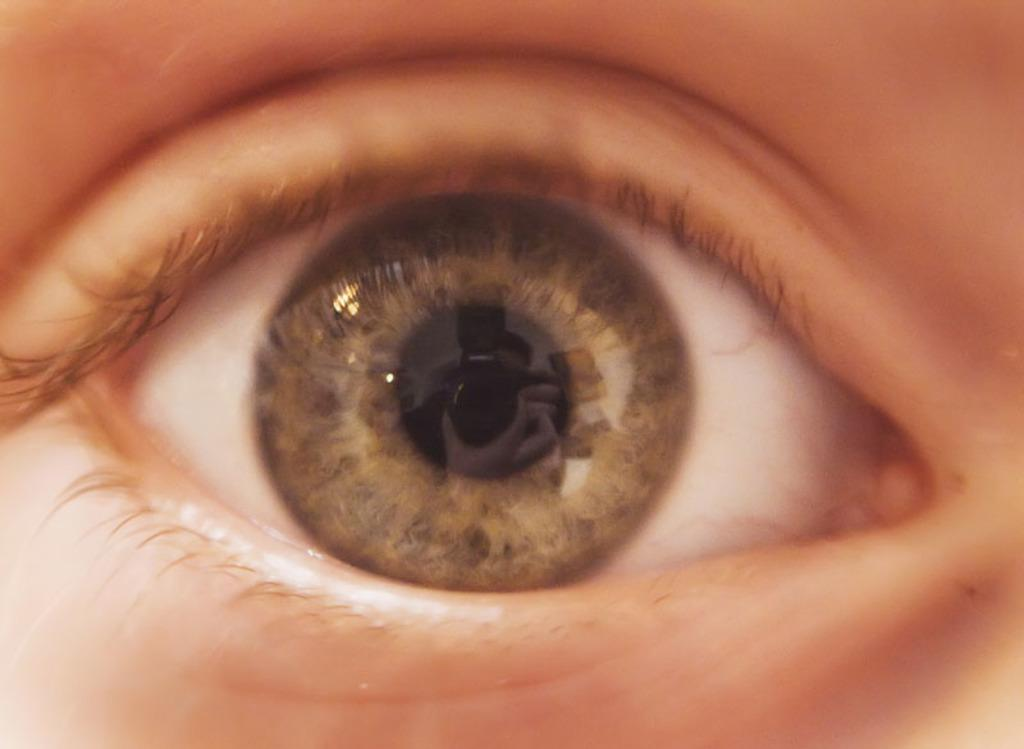What is the main subject of the image? The main subject of the image is a human eye. What features can be observed on the human eye? The human eye has eyelids. What type of jelly can be seen in the image? There is no jelly present in the image; it features a human eye with eyelids. How many houses are visible in the image? There are no houses visible in the image; it features a human eye with eyelids. 